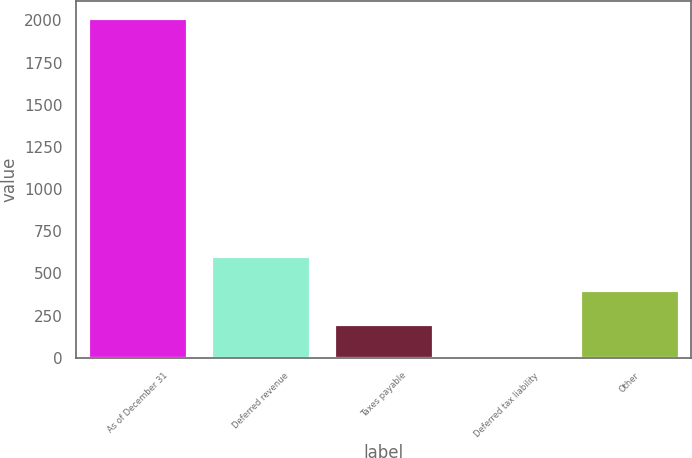Convert chart to OTSL. <chart><loc_0><loc_0><loc_500><loc_500><bar_chart><fcel>As of December 31<fcel>Deferred revenue<fcel>Taxes payable<fcel>Deferred tax liability<fcel>Other<nl><fcel>2014<fcel>605.6<fcel>203.2<fcel>2<fcel>404.4<nl></chart> 